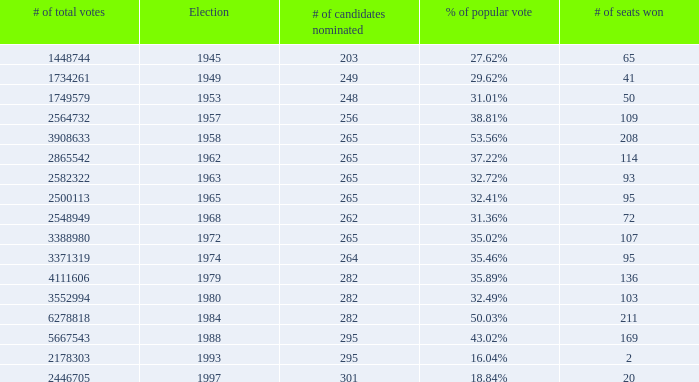What is the # of seats one for the election in 1974? 95.0. 